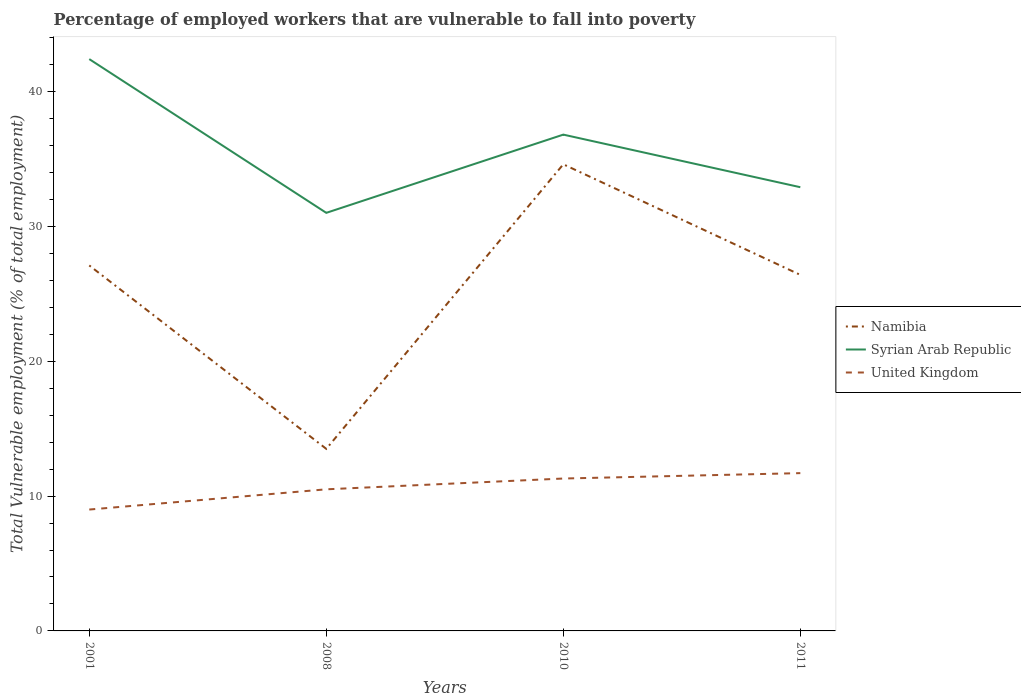Across all years, what is the maximum percentage of employed workers who are vulnerable to fall into poverty in United Kingdom?
Give a very brief answer. 9. In which year was the percentage of employed workers who are vulnerable to fall into poverty in Namibia maximum?
Your answer should be very brief. 2008. What is the total percentage of employed workers who are vulnerable to fall into poverty in United Kingdom in the graph?
Your answer should be very brief. -0.4. What is the difference between the highest and the second highest percentage of employed workers who are vulnerable to fall into poverty in Syrian Arab Republic?
Provide a succinct answer. 11.4. How many years are there in the graph?
Make the answer very short. 4. What is the difference between two consecutive major ticks on the Y-axis?
Your answer should be compact. 10. Does the graph contain any zero values?
Ensure brevity in your answer.  No. Where does the legend appear in the graph?
Provide a short and direct response. Center right. How are the legend labels stacked?
Your response must be concise. Vertical. What is the title of the graph?
Ensure brevity in your answer.  Percentage of employed workers that are vulnerable to fall into poverty. Does "El Salvador" appear as one of the legend labels in the graph?
Make the answer very short. No. What is the label or title of the X-axis?
Your answer should be compact. Years. What is the label or title of the Y-axis?
Ensure brevity in your answer.  Total Vulnerable employment (% of total employment). What is the Total Vulnerable employment (% of total employment) of Namibia in 2001?
Ensure brevity in your answer.  27.1. What is the Total Vulnerable employment (% of total employment) in Syrian Arab Republic in 2001?
Your response must be concise. 42.4. What is the Total Vulnerable employment (% of total employment) in United Kingdom in 2001?
Your answer should be very brief. 9. What is the Total Vulnerable employment (% of total employment) in Syrian Arab Republic in 2008?
Provide a short and direct response. 31. What is the Total Vulnerable employment (% of total employment) of United Kingdom in 2008?
Your answer should be compact. 10.5. What is the Total Vulnerable employment (% of total employment) in Namibia in 2010?
Give a very brief answer. 34.6. What is the Total Vulnerable employment (% of total employment) of Syrian Arab Republic in 2010?
Your answer should be compact. 36.8. What is the Total Vulnerable employment (% of total employment) of United Kingdom in 2010?
Your answer should be very brief. 11.3. What is the Total Vulnerable employment (% of total employment) in Namibia in 2011?
Make the answer very short. 26.4. What is the Total Vulnerable employment (% of total employment) of Syrian Arab Republic in 2011?
Provide a succinct answer. 32.9. What is the Total Vulnerable employment (% of total employment) in United Kingdom in 2011?
Provide a short and direct response. 11.7. Across all years, what is the maximum Total Vulnerable employment (% of total employment) in Namibia?
Ensure brevity in your answer.  34.6. Across all years, what is the maximum Total Vulnerable employment (% of total employment) in Syrian Arab Republic?
Provide a succinct answer. 42.4. Across all years, what is the maximum Total Vulnerable employment (% of total employment) of United Kingdom?
Ensure brevity in your answer.  11.7. Across all years, what is the minimum Total Vulnerable employment (% of total employment) in Namibia?
Ensure brevity in your answer.  13.5. Across all years, what is the minimum Total Vulnerable employment (% of total employment) in Syrian Arab Republic?
Make the answer very short. 31. Across all years, what is the minimum Total Vulnerable employment (% of total employment) in United Kingdom?
Make the answer very short. 9. What is the total Total Vulnerable employment (% of total employment) in Namibia in the graph?
Offer a very short reply. 101.6. What is the total Total Vulnerable employment (% of total employment) of Syrian Arab Republic in the graph?
Give a very brief answer. 143.1. What is the total Total Vulnerable employment (% of total employment) of United Kingdom in the graph?
Provide a short and direct response. 42.5. What is the difference between the Total Vulnerable employment (% of total employment) in Namibia in 2001 and that in 2008?
Give a very brief answer. 13.6. What is the difference between the Total Vulnerable employment (% of total employment) of Syrian Arab Republic in 2001 and that in 2008?
Your answer should be compact. 11.4. What is the difference between the Total Vulnerable employment (% of total employment) in United Kingdom in 2001 and that in 2008?
Your answer should be very brief. -1.5. What is the difference between the Total Vulnerable employment (% of total employment) in Syrian Arab Republic in 2001 and that in 2010?
Make the answer very short. 5.6. What is the difference between the Total Vulnerable employment (% of total employment) in Namibia in 2001 and that in 2011?
Offer a terse response. 0.7. What is the difference between the Total Vulnerable employment (% of total employment) of Syrian Arab Republic in 2001 and that in 2011?
Your response must be concise. 9.5. What is the difference between the Total Vulnerable employment (% of total employment) in Namibia in 2008 and that in 2010?
Provide a succinct answer. -21.1. What is the difference between the Total Vulnerable employment (% of total employment) of Syrian Arab Republic in 2008 and that in 2010?
Offer a terse response. -5.8. What is the difference between the Total Vulnerable employment (% of total employment) in United Kingdom in 2008 and that in 2010?
Your response must be concise. -0.8. What is the difference between the Total Vulnerable employment (% of total employment) of Syrian Arab Republic in 2008 and that in 2011?
Your response must be concise. -1.9. What is the difference between the Total Vulnerable employment (% of total employment) of Namibia in 2010 and that in 2011?
Your response must be concise. 8.2. What is the difference between the Total Vulnerable employment (% of total employment) in Syrian Arab Republic in 2010 and that in 2011?
Your response must be concise. 3.9. What is the difference between the Total Vulnerable employment (% of total employment) of United Kingdom in 2010 and that in 2011?
Give a very brief answer. -0.4. What is the difference between the Total Vulnerable employment (% of total employment) of Namibia in 2001 and the Total Vulnerable employment (% of total employment) of Syrian Arab Republic in 2008?
Ensure brevity in your answer.  -3.9. What is the difference between the Total Vulnerable employment (% of total employment) in Namibia in 2001 and the Total Vulnerable employment (% of total employment) in United Kingdom in 2008?
Your answer should be compact. 16.6. What is the difference between the Total Vulnerable employment (% of total employment) of Syrian Arab Republic in 2001 and the Total Vulnerable employment (% of total employment) of United Kingdom in 2008?
Offer a very short reply. 31.9. What is the difference between the Total Vulnerable employment (% of total employment) in Namibia in 2001 and the Total Vulnerable employment (% of total employment) in United Kingdom in 2010?
Ensure brevity in your answer.  15.8. What is the difference between the Total Vulnerable employment (% of total employment) in Syrian Arab Republic in 2001 and the Total Vulnerable employment (% of total employment) in United Kingdom in 2010?
Your response must be concise. 31.1. What is the difference between the Total Vulnerable employment (% of total employment) in Syrian Arab Republic in 2001 and the Total Vulnerable employment (% of total employment) in United Kingdom in 2011?
Ensure brevity in your answer.  30.7. What is the difference between the Total Vulnerable employment (% of total employment) in Namibia in 2008 and the Total Vulnerable employment (% of total employment) in Syrian Arab Republic in 2010?
Ensure brevity in your answer.  -23.3. What is the difference between the Total Vulnerable employment (% of total employment) of Namibia in 2008 and the Total Vulnerable employment (% of total employment) of United Kingdom in 2010?
Your answer should be very brief. 2.2. What is the difference between the Total Vulnerable employment (% of total employment) in Namibia in 2008 and the Total Vulnerable employment (% of total employment) in Syrian Arab Republic in 2011?
Keep it short and to the point. -19.4. What is the difference between the Total Vulnerable employment (% of total employment) in Syrian Arab Republic in 2008 and the Total Vulnerable employment (% of total employment) in United Kingdom in 2011?
Your answer should be very brief. 19.3. What is the difference between the Total Vulnerable employment (% of total employment) of Namibia in 2010 and the Total Vulnerable employment (% of total employment) of Syrian Arab Republic in 2011?
Your response must be concise. 1.7. What is the difference between the Total Vulnerable employment (% of total employment) in Namibia in 2010 and the Total Vulnerable employment (% of total employment) in United Kingdom in 2011?
Offer a terse response. 22.9. What is the difference between the Total Vulnerable employment (% of total employment) in Syrian Arab Republic in 2010 and the Total Vulnerable employment (% of total employment) in United Kingdom in 2011?
Your response must be concise. 25.1. What is the average Total Vulnerable employment (% of total employment) of Namibia per year?
Your response must be concise. 25.4. What is the average Total Vulnerable employment (% of total employment) in Syrian Arab Republic per year?
Provide a succinct answer. 35.77. What is the average Total Vulnerable employment (% of total employment) of United Kingdom per year?
Provide a short and direct response. 10.62. In the year 2001, what is the difference between the Total Vulnerable employment (% of total employment) of Namibia and Total Vulnerable employment (% of total employment) of Syrian Arab Republic?
Make the answer very short. -15.3. In the year 2001, what is the difference between the Total Vulnerable employment (% of total employment) in Syrian Arab Republic and Total Vulnerable employment (% of total employment) in United Kingdom?
Offer a terse response. 33.4. In the year 2008, what is the difference between the Total Vulnerable employment (% of total employment) in Namibia and Total Vulnerable employment (% of total employment) in Syrian Arab Republic?
Offer a very short reply. -17.5. In the year 2008, what is the difference between the Total Vulnerable employment (% of total employment) of Namibia and Total Vulnerable employment (% of total employment) of United Kingdom?
Offer a terse response. 3. In the year 2010, what is the difference between the Total Vulnerable employment (% of total employment) of Namibia and Total Vulnerable employment (% of total employment) of Syrian Arab Republic?
Your response must be concise. -2.2. In the year 2010, what is the difference between the Total Vulnerable employment (% of total employment) in Namibia and Total Vulnerable employment (% of total employment) in United Kingdom?
Provide a succinct answer. 23.3. In the year 2010, what is the difference between the Total Vulnerable employment (% of total employment) of Syrian Arab Republic and Total Vulnerable employment (% of total employment) of United Kingdom?
Give a very brief answer. 25.5. In the year 2011, what is the difference between the Total Vulnerable employment (% of total employment) in Syrian Arab Republic and Total Vulnerable employment (% of total employment) in United Kingdom?
Provide a short and direct response. 21.2. What is the ratio of the Total Vulnerable employment (% of total employment) in Namibia in 2001 to that in 2008?
Offer a very short reply. 2.01. What is the ratio of the Total Vulnerable employment (% of total employment) of Syrian Arab Republic in 2001 to that in 2008?
Make the answer very short. 1.37. What is the ratio of the Total Vulnerable employment (% of total employment) of United Kingdom in 2001 to that in 2008?
Provide a succinct answer. 0.86. What is the ratio of the Total Vulnerable employment (% of total employment) in Namibia in 2001 to that in 2010?
Your answer should be compact. 0.78. What is the ratio of the Total Vulnerable employment (% of total employment) in Syrian Arab Republic in 2001 to that in 2010?
Provide a succinct answer. 1.15. What is the ratio of the Total Vulnerable employment (% of total employment) of United Kingdom in 2001 to that in 2010?
Ensure brevity in your answer.  0.8. What is the ratio of the Total Vulnerable employment (% of total employment) of Namibia in 2001 to that in 2011?
Offer a terse response. 1.03. What is the ratio of the Total Vulnerable employment (% of total employment) in Syrian Arab Republic in 2001 to that in 2011?
Give a very brief answer. 1.29. What is the ratio of the Total Vulnerable employment (% of total employment) of United Kingdom in 2001 to that in 2011?
Ensure brevity in your answer.  0.77. What is the ratio of the Total Vulnerable employment (% of total employment) of Namibia in 2008 to that in 2010?
Your answer should be compact. 0.39. What is the ratio of the Total Vulnerable employment (% of total employment) of Syrian Arab Republic in 2008 to that in 2010?
Your answer should be very brief. 0.84. What is the ratio of the Total Vulnerable employment (% of total employment) in United Kingdom in 2008 to that in 2010?
Provide a succinct answer. 0.93. What is the ratio of the Total Vulnerable employment (% of total employment) in Namibia in 2008 to that in 2011?
Offer a very short reply. 0.51. What is the ratio of the Total Vulnerable employment (% of total employment) of Syrian Arab Republic in 2008 to that in 2011?
Provide a short and direct response. 0.94. What is the ratio of the Total Vulnerable employment (% of total employment) in United Kingdom in 2008 to that in 2011?
Provide a succinct answer. 0.9. What is the ratio of the Total Vulnerable employment (% of total employment) in Namibia in 2010 to that in 2011?
Your answer should be compact. 1.31. What is the ratio of the Total Vulnerable employment (% of total employment) in Syrian Arab Republic in 2010 to that in 2011?
Offer a terse response. 1.12. What is the ratio of the Total Vulnerable employment (% of total employment) in United Kingdom in 2010 to that in 2011?
Your response must be concise. 0.97. What is the difference between the highest and the second highest Total Vulnerable employment (% of total employment) of Syrian Arab Republic?
Provide a short and direct response. 5.6. What is the difference between the highest and the second highest Total Vulnerable employment (% of total employment) in United Kingdom?
Offer a terse response. 0.4. What is the difference between the highest and the lowest Total Vulnerable employment (% of total employment) in Namibia?
Offer a terse response. 21.1. What is the difference between the highest and the lowest Total Vulnerable employment (% of total employment) in Syrian Arab Republic?
Your answer should be very brief. 11.4. 